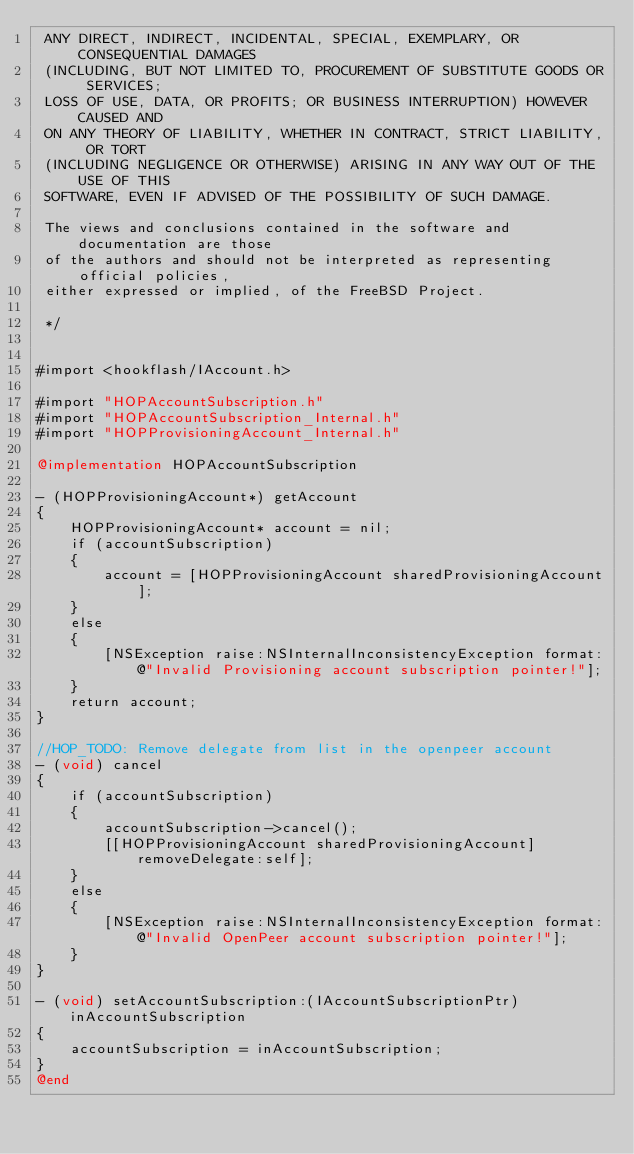Convert code to text. <code><loc_0><loc_0><loc_500><loc_500><_ObjectiveC_> ANY DIRECT, INDIRECT, INCIDENTAL, SPECIAL, EXEMPLARY, OR CONSEQUENTIAL DAMAGES
 (INCLUDING, BUT NOT LIMITED TO, PROCUREMENT OF SUBSTITUTE GOODS OR SERVICES;
 LOSS OF USE, DATA, OR PROFITS; OR BUSINESS INTERRUPTION) HOWEVER CAUSED AND
 ON ANY THEORY OF LIABILITY, WHETHER IN CONTRACT, STRICT LIABILITY, OR TORT
 (INCLUDING NEGLIGENCE OR OTHERWISE) ARISING IN ANY WAY OUT OF THE USE OF THIS
 SOFTWARE, EVEN IF ADVISED OF THE POSSIBILITY OF SUCH DAMAGE.
 
 The views and conclusions contained in the software and documentation are those
 of the authors and should not be interpreted as representing official policies,
 either expressed or implied, of the FreeBSD Project.
 
 */


#import <hookflash/IAccount.h>

#import "HOPAccountSubscription.h"
#import "HOPAccountSubscription_Internal.h"
#import "HOPProvisioningAccount_Internal.h"

@implementation HOPAccountSubscription

- (HOPProvisioningAccount*) getAccount
{
    HOPProvisioningAccount* account = nil;
    if (accountSubscription)
    {
        account = [HOPProvisioningAccount sharedProvisioningAccount];
    }
    else
    {
        [NSException raise:NSInternalInconsistencyException format:@"Invalid Provisioning account subscription pointer!"];
    }
    return account;
}

//HOP_TODO: Remove delegate from list in the openpeer account 
- (void) cancel
{
    if (accountSubscription)
    {
        accountSubscription->cancel();
        [[HOPProvisioningAccount sharedProvisioningAccount] removeDelegate:self];
    }
    else
    {
        [NSException raise:NSInternalInconsistencyException format:@"Invalid OpenPeer account subscription pointer!"];
    }
}

- (void) setAccountSubscription:(IAccountSubscriptionPtr) inAccountSubscription
{
    accountSubscription = inAccountSubscription;
}
@end
</code> 